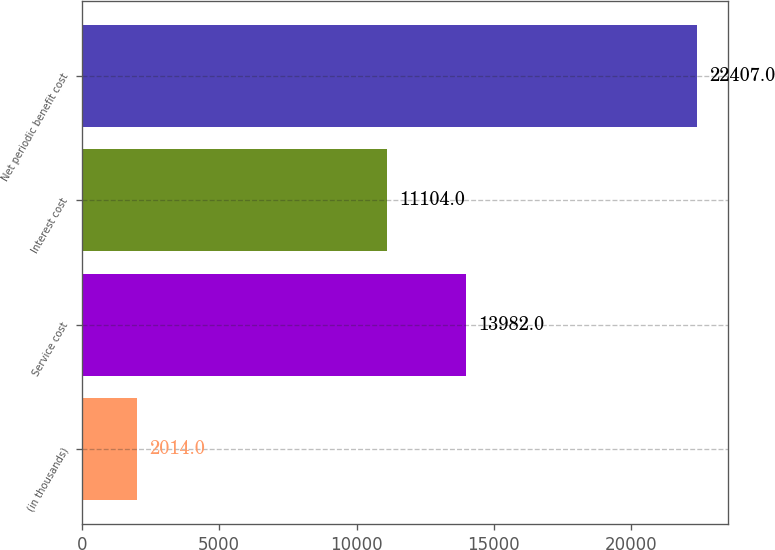Convert chart. <chart><loc_0><loc_0><loc_500><loc_500><bar_chart><fcel>(in thousands)<fcel>Service cost<fcel>Interest cost<fcel>Net periodic benefit cost<nl><fcel>2014<fcel>13982<fcel>11104<fcel>22407<nl></chart> 